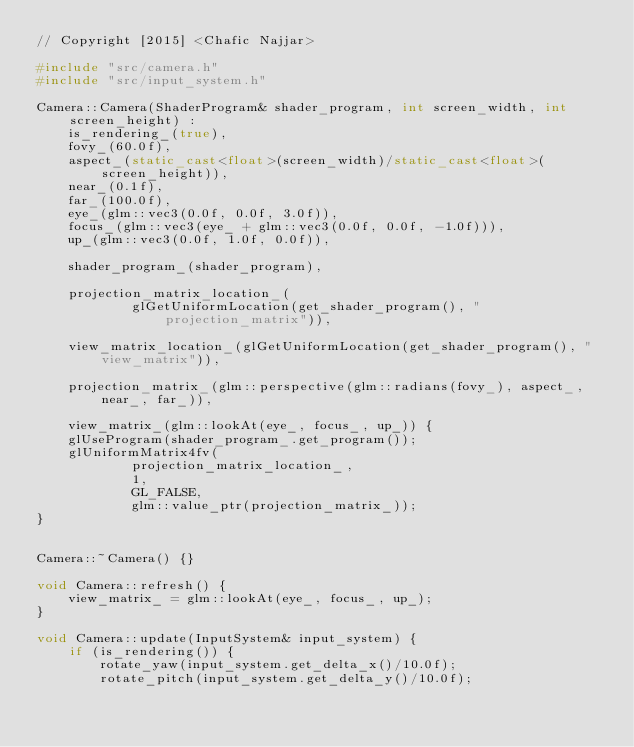<code> <loc_0><loc_0><loc_500><loc_500><_C++_>// Copyright [2015] <Chafic Najjar>

#include "src/camera.h"
#include "src/input_system.h"

Camera::Camera(ShaderProgram& shader_program, int screen_width, int screen_height) :
    is_rendering_(true),
    fovy_(60.0f),
    aspect_(static_cast<float>(screen_width)/static_cast<float>(screen_height)),
    near_(0.1f),
    far_(100.0f),
    eye_(glm::vec3(0.0f, 0.0f, 3.0f)),
    focus_(glm::vec3(eye_ + glm::vec3(0.0f, 0.0f, -1.0f))),
    up_(glm::vec3(0.0f, 1.0f, 0.0f)),

    shader_program_(shader_program),

    projection_matrix_location_(
            glGetUniformLocation(get_shader_program(), "projection_matrix")),

    view_matrix_location_(glGetUniformLocation(get_shader_program(), "view_matrix")),

    projection_matrix_(glm::perspective(glm::radians(fovy_), aspect_, near_, far_)),

    view_matrix_(glm::lookAt(eye_, focus_, up_)) {
    glUseProgram(shader_program_.get_program());
    glUniformMatrix4fv(
            projection_matrix_location_,
            1,
            GL_FALSE,
            glm::value_ptr(projection_matrix_));
}


Camera::~Camera() {}

void Camera::refresh() {
    view_matrix_ = glm::lookAt(eye_, focus_, up_);
}

void Camera::update(InputSystem& input_system) {
    if (is_rendering()) {
        rotate_yaw(input_system.get_delta_x()/10.0f);
        rotate_pitch(input_system.get_delta_y()/10.0f);
</code> 